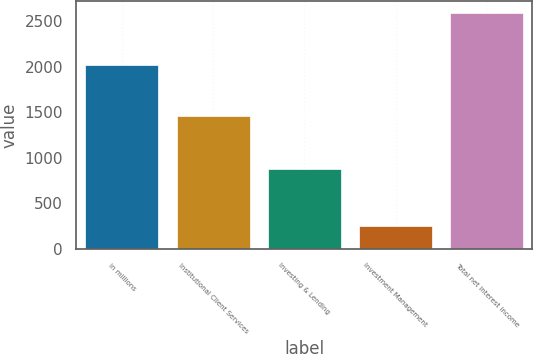<chart> <loc_0><loc_0><loc_500><loc_500><bar_chart><fcel>in millions<fcel>Institutional Client Services<fcel>Investing & Lending<fcel>Investment Management<fcel>Total net interest income<nl><fcel>2016<fcel>1456<fcel>880<fcel>251<fcel>2587<nl></chart> 